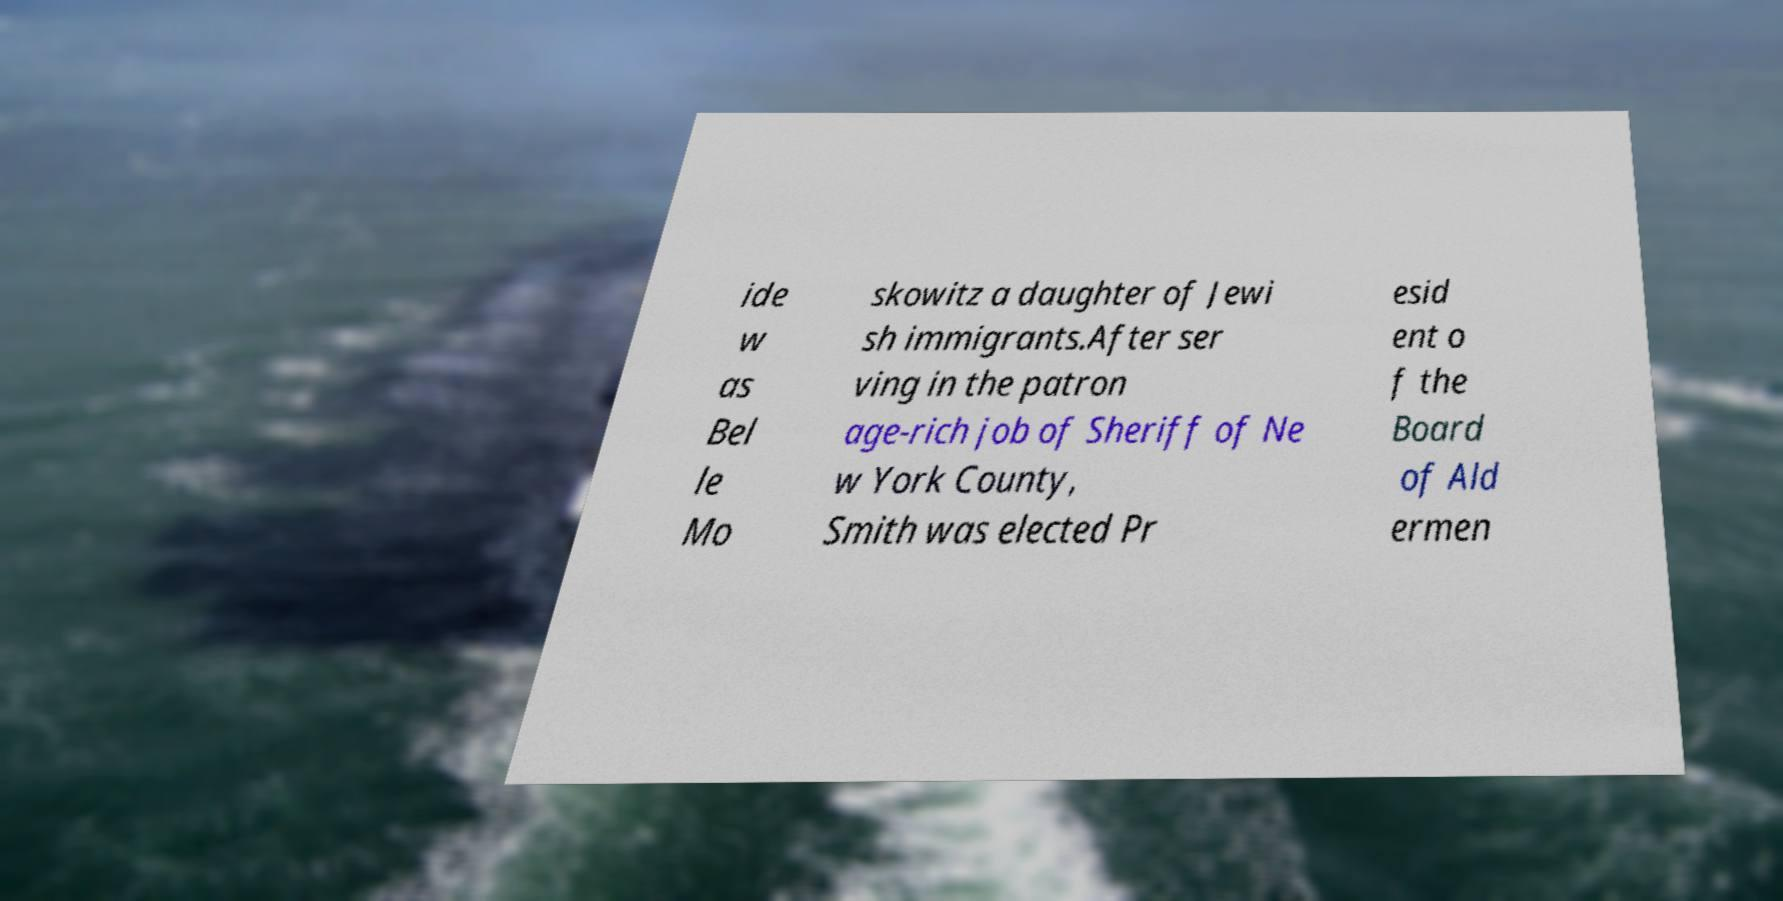What messages or text are displayed in this image? I need them in a readable, typed format. ide w as Bel le Mo skowitz a daughter of Jewi sh immigrants.After ser ving in the patron age-rich job of Sheriff of Ne w York County, Smith was elected Pr esid ent o f the Board of Ald ermen 